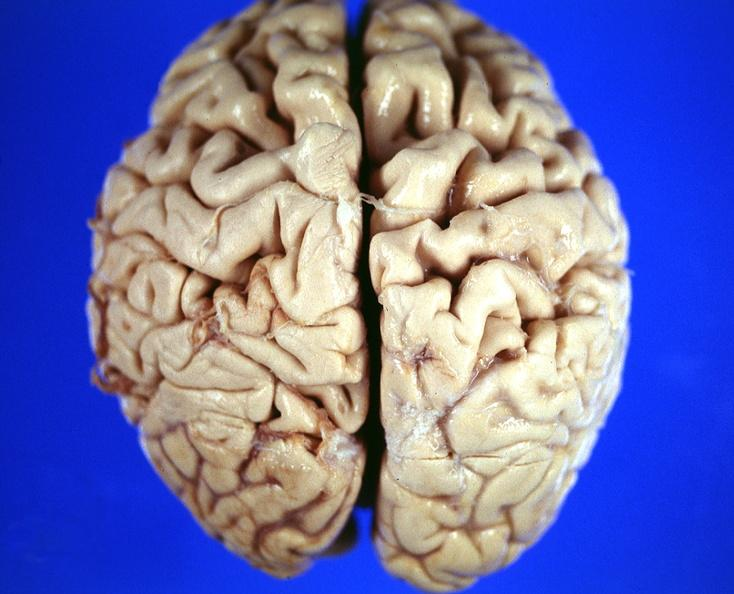what does this image show?
Answer the question using a single word or phrase. Brain 